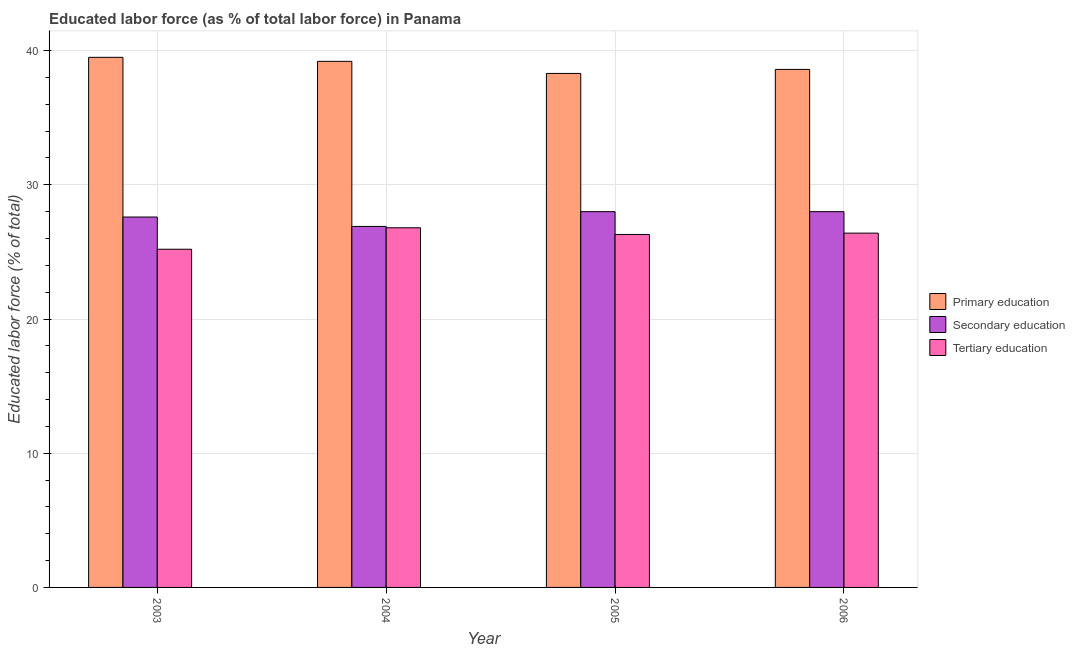How many different coloured bars are there?
Give a very brief answer. 3. How many groups of bars are there?
Make the answer very short. 4. Are the number of bars per tick equal to the number of legend labels?
Make the answer very short. Yes. Are the number of bars on each tick of the X-axis equal?
Keep it short and to the point. Yes. How many bars are there on the 4th tick from the left?
Ensure brevity in your answer.  3. How many bars are there on the 3rd tick from the right?
Ensure brevity in your answer.  3. What is the label of the 1st group of bars from the left?
Offer a very short reply. 2003. In how many cases, is the number of bars for a given year not equal to the number of legend labels?
Give a very brief answer. 0. Across all years, what is the maximum percentage of labor force who received primary education?
Ensure brevity in your answer.  39.5. Across all years, what is the minimum percentage of labor force who received primary education?
Ensure brevity in your answer.  38.3. What is the total percentage of labor force who received secondary education in the graph?
Offer a very short reply. 110.5. What is the difference between the percentage of labor force who received secondary education in 2003 and that in 2006?
Offer a terse response. -0.4. What is the difference between the percentage of labor force who received primary education in 2006 and the percentage of labor force who received tertiary education in 2004?
Ensure brevity in your answer.  -0.6. What is the average percentage of labor force who received tertiary education per year?
Your response must be concise. 26.17. In how many years, is the percentage of labor force who received tertiary education greater than 6 %?
Your answer should be very brief. 4. What is the ratio of the percentage of labor force who received primary education in 2003 to that in 2005?
Give a very brief answer. 1.03. Is the percentage of labor force who received secondary education in 2004 less than that in 2005?
Your answer should be very brief. Yes. What is the difference between the highest and the second highest percentage of labor force who received tertiary education?
Offer a terse response. 0.4. What is the difference between the highest and the lowest percentage of labor force who received secondary education?
Provide a succinct answer. 1.1. What does the 3rd bar from the left in 2005 represents?
Provide a succinct answer. Tertiary education. What does the 2nd bar from the right in 2006 represents?
Offer a terse response. Secondary education. Are all the bars in the graph horizontal?
Your response must be concise. No. How many years are there in the graph?
Make the answer very short. 4. Are the values on the major ticks of Y-axis written in scientific E-notation?
Make the answer very short. No. Does the graph contain any zero values?
Provide a short and direct response. No. Does the graph contain grids?
Keep it short and to the point. Yes. How are the legend labels stacked?
Provide a short and direct response. Vertical. What is the title of the graph?
Offer a very short reply. Educated labor force (as % of total labor force) in Panama. Does "Domestic" appear as one of the legend labels in the graph?
Your answer should be very brief. No. What is the label or title of the Y-axis?
Your response must be concise. Educated labor force (% of total). What is the Educated labor force (% of total) in Primary education in 2003?
Offer a very short reply. 39.5. What is the Educated labor force (% of total) of Secondary education in 2003?
Your response must be concise. 27.6. What is the Educated labor force (% of total) in Tertiary education in 2003?
Your answer should be very brief. 25.2. What is the Educated labor force (% of total) of Primary education in 2004?
Offer a terse response. 39.2. What is the Educated labor force (% of total) in Secondary education in 2004?
Make the answer very short. 26.9. What is the Educated labor force (% of total) of Tertiary education in 2004?
Provide a succinct answer. 26.8. What is the Educated labor force (% of total) of Primary education in 2005?
Make the answer very short. 38.3. What is the Educated labor force (% of total) of Secondary education in 2005?
Keep it short and to the point. 28. What is the Educated labor force (% of total) in Tertiary education in 2005?
Your response must be concise. 26.3. What is the Educated labor force (% of total) of Primary education in 2006?
Make the answer very short. 38.6. What is the Educated labor force (% of total) of Tertiary education in 2006?
Offer a very short reply. 26.4. Across all years, what is the maximum Educated labor force (% of total) of Primary education?
Provide a succinct answer. 39.5. Across all years, what is the maximum Educated labor force (% of total) of Tertiary education?
Make the answer very short. 26.8. Across all years, what is the minimum Educated labor force (% of total) of Primary education?
Ensure brevity in your answer.  38.3. Across all years, what is the minimum Educated labor force (% of total) of Secondary education?
Give a very brief answer. 26.9. Across all years, what is the minimum Educated labor force (% of total) of Tertiary education?
Provide a short and direct response. 25.2. What is the total Educated labor force (% of total) in Primary education in the graph?
Give a very brief answer. 155.6. What is the total Educated labor force (% of total) in Secondary education in the graph?
Give a very brief answer. 110.5. What is the total Educated labor force (% of total) of Tertiary education in the graph?
Make the answer very short. 104.7. What is the difference between the Educated labor force (% of total) of Primary education in 2003 and that in 2004?
Your answer should be very brief. 0.3. What is the difference between the Educated labor force (% of total) of Secondary education in 2003 and that in 2005?
Offer a terse response. -0.4. What is the difference between the Educated labor force (% of total) in Tertiary education in 2003 and that in 2005?
Ensure brevity in your answer.  -1.1. What is the difference between the Educated labor force (% of total) of Secondary education in 2003 and that in 2006?
Offer a very short reply. -0.4. What is the difference between the Educated labor force (% of total) in Tertiary education in 2003 and that in 2006?
Provide a short and direct response. -1.2. What is the difference between the Educated labor force (% of total) in Tertiary education in 2004 and that in 2005?
Offer a terse response. 0.5. What is the difference between the Educated labor force (% of total) of Primary education in 2004 and that in 2006?
Give a very brief answer. 0.6. What is the difference between the Educated labor force (% of total) of Primary education in 2005 and that in 2006?
Give a very brief answer. -0.3. What is the difference between the Educated labor force (% of total) of Secondary education in 2005 and that in 2006?
Ensure brevity in your answer.  0. What is the difference between the Educated labor force (% of total) in Tertiary education in 2005 and that in 2006?
Ensure brevity in your answer.  -0.1. What is the difference between the Educated labor force (% of total) of Primary education in 2003 and the Educated labor force (% of total) of Secondary education in 2004?
Your answer should be compact. 12.6. What is the difference between the Educated labor force (% of total) of Primary education in 2003 and the Educated labor force (% of total) of Tertiary education in 2005?
Give a very brief answer. 13.2. What is the difference between the Educated labor force (% of total) of Primary education in 2003 and the Educated labor force (% of total) of Secondary education in 2006?
Your answer should be very brief. 11.5. What is the difference between the Educated labor force (% of total) of Primary education in 2004 and the Educated labor force (% of total) of Secondary education in 2005?
Make the answer very short. 11.2. What is the difference between the Educated labor force (% of total) of Primary education in 2004 and the Educated labor force (% of total) of Tertiary education in 2005?
Ensure brevity in your answer.  12.9. What is the difference between the Educated labor force (% of total) of Secondary education in 2004 and the Educated labor force (% of total) of Tertiary education in 2005?
Make the answer very short. 0.6. What is the difference between the Educated labor force (% of total) in Primary education in 2005 and the Educated labor force (% of total) in Secondary education in 2006?
Provide a short and direct response. 10.3. What is the difference between the Educated labor force (% of total) in Primary education in 2005 and the Educated labor force (% of total) in Tertiary education in 2006?
Offer a terse response. 11.9. What is the difference between the Educated labor force (% of total) in Secondary education in 2005 and the Educated labor force (% of total) in Tertiary education in 2006?
Your answer should be very brief. 1.6. What is the average Educated labor force (% of total) of Primary education per year?
Your response must be concise. 38.9. What is the average Educated labor force (% of total) in Secondary education per year?
Ensure brevity in your answer.  27.62. What is the average Educated labor force (% of total) of Tertiary education per year?
Provide a short and direct response. 26.18. In the year 2004, what is the difference between the Educated labor force (% of total) of Primary education and Educated labor force (% of total) of Secondary education?
Keep it short and to the point. 12.3. In the year 2004, what is the difference between the Educated labor force (% of total) of Primary education and Educated labor force (% of total) of Tertiary education?
Your response must be concise. 12.4. In the year 2005, what is the difference between the Educated labor force (% of total) in Primary education and Educated labor force (% of total) in Secondary education?
Your answer should be compact. 10.3. In the year 2005, what is the difference between the Educated labor force (% of total) in Primary education and Educated labor force (% of total) in Tertiary education?
Provide a succinct answer. 12. In the year 2006, what is the difference between the Educated labor force (% of total) in Primary education and Educated labor force (% of total) in Secondary education?
Provide a short and direct response. 10.6. In the year 2006, what is the difference between the Educated labor force (% of total) in Primary education and Educated labor force (% of total) in Tertiary education?
Provide a short and direct response. 12.2. In the year 2006, what is the difference between the Educated labor force (% of total) in Secondary education and Educated labor force (% of total) in Tertiary education?
Your answer should be very brief. 1.6. What is the ratio of the Educated labor force (% of total) of Primary education in 2003 to that in 2004?
Make the answer very short. 1.01. What is the ratio of the Educated labor force (% of total) in Tertiary education in 2003 to that in 2004?
Ensure brevity in your answer.  0.94. What is the ratio of the Educated labor force (% of total) in Primary education in 2003 to that in 2005?
Provide a short and direct response. 1.03. What is the ratio of the Educated labor force (% of total) in Secondary education in 2003 to that in 2005?
Make the answer very short. 0.99. What is the ratio of the Educated labor force (% of total) in Tertiary education in 2003 to that in 2005?
Make the answer very short. 0.96. What is the ratio of the Educated labor force (% of total) of Primary education in 2003 to that in 2006?
Make the answer very short. 1.02. What is the ratio of the Educated labor force (% of total) of Secondary education in 2003 to that in 2006?
Ensure brevity in your answer.  0.99. What is the ratio of the Educated labor force (% of total) of Tertiary education in 2003 to that in 2006?
Provide a short and direct response. 0.95. What is the ratio of the Educated labor force (% of total) of Primary education in 2004 to that in 2005?
Your answer should be compact. 1.02. What is the ratio of the Educated labor force (% of total) of Secondary education in 2004 to that in 2005?
Your response must be concise. 0.96. What is the ratio of the Educated labor force (% of total) in Tertiary education in 2004 to that in 2005?
Ensure brevity in your answer.  1.02. What is the ratio of the Educated labor force (% of total) in Primary education in 2004 to that in 2006?
Offer a very short reply. 1.02. What is the ratio of the Educated labor force (% of total) of Secondary education in 2004 to that in 2006?
Your answer should be compact. 0.96. What is the ratio of the Educated labor force (% of total) in Tertiary education in 2004 to that in 2006?
Give a very brief answer. 1.02. What is the ratio of the Educated labor force (% of total) in Primary education in 2005 to that in 2006?
Your answer should be very brief. 0.99. What is the difference between the highest and the second highest Educated labor force (% of total) in Tertiary education?
Ensure brevity in your answer.  0.4. What is the difference between the highest and the lowest Educated labor force (% of total) of Secondary education?
Your response must be concise. 1.1. 